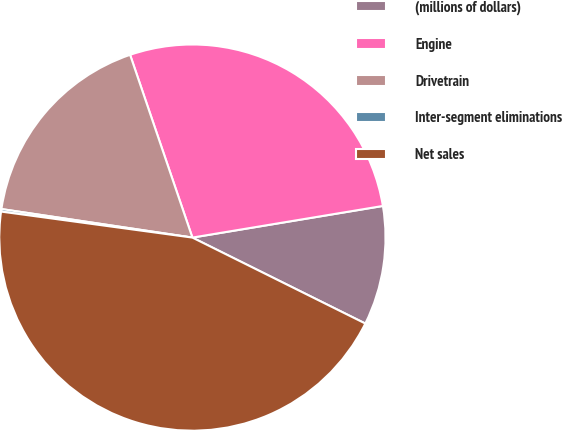<chart> <loc_0><loc_0><loc_500><loc_500><pie_chart><fcel>(millions of dollars)<fcel>Engine<fcel>Drivetrain<fcel>Inter-segment eliminations<fcel>Net sales<nl><fcel>9.96%<fcel>27.61%<fcel>17.41%<fcel>0.21%<fcel>44.81%<nl></chart> 